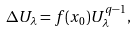<formula> <loc_0><loc_0><loc_500><loc_500>\Delta U _ { \lambda } = f ( x _ { 0 } ) U _ { \lambda } ^ { q - 1 } ,</formula> 